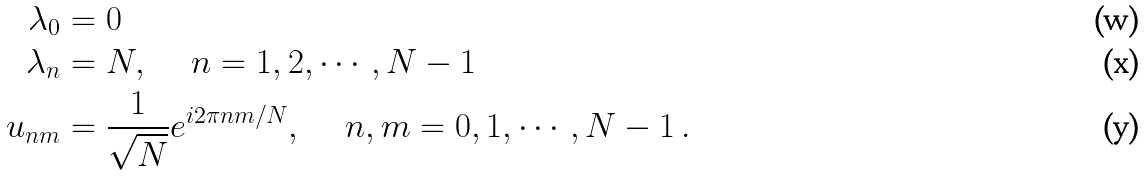<formula> <loc_0><loc_0><loc_500><loc_500>\lambda _ { 0 } & = 0 \\ \lambda _ { n } & = N , \quad \ n = 1 , 2 , \cdots , N - 1 \\ u _ { n m } & = \frac { 1 } { \sqrt { N } } e ^ { i 2 \pi n m / N } , \quad \ n , m = 0 , 1 , \cdots , N - 1 \, .</formula> 